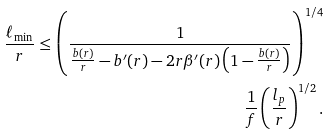Convert formula to latex. <formula><loc_0><loc_0><loc_500><loc_500>\frac { \ell _ { \min } } { r } \leq \left ( \frac { 1 } { \frac { b ( r ) } { r } - b ^ { \prime } ( r ) - 2 r \beta ^ { \prime } ( r ) \left ( 1 - \frac { b ( r ) } { r } \right ) } \right ) ^ { 1 / 4 } \\ \frac { 1 } { f } \left ( \frac { l _ { p } } { r } \right ) ^ { 1 / 2 } .</formula> 